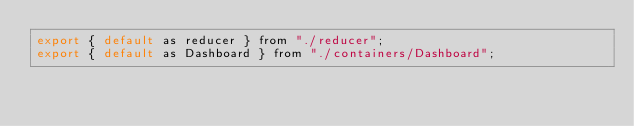<code> <loc_0><loc_0><loc_500><loc_500><_JavaScript_>export { default as reducer } from "./reducer";
export { default as Dashboard } from "./containers/Dashboard";
</code> 